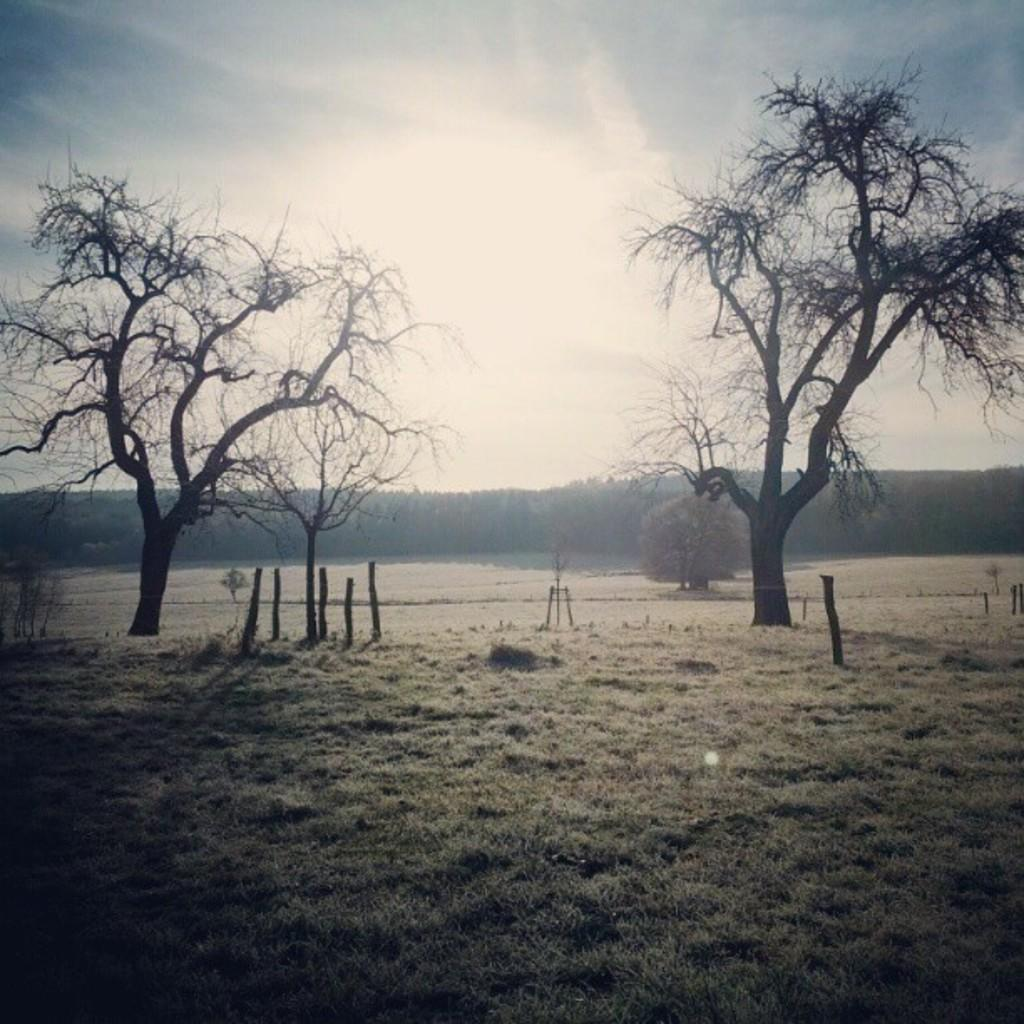What type of vegetation is present in the image? There are trees in the image. What is covering the ground in the image? There is grass on the ground in the image. How would you describe the sky in the image? The sky is blue and cloudy in the image. Can you see a boot in the front of the image? There is no boot present in the image. How many legs are visible in the image? There are no legs visible in the image. 